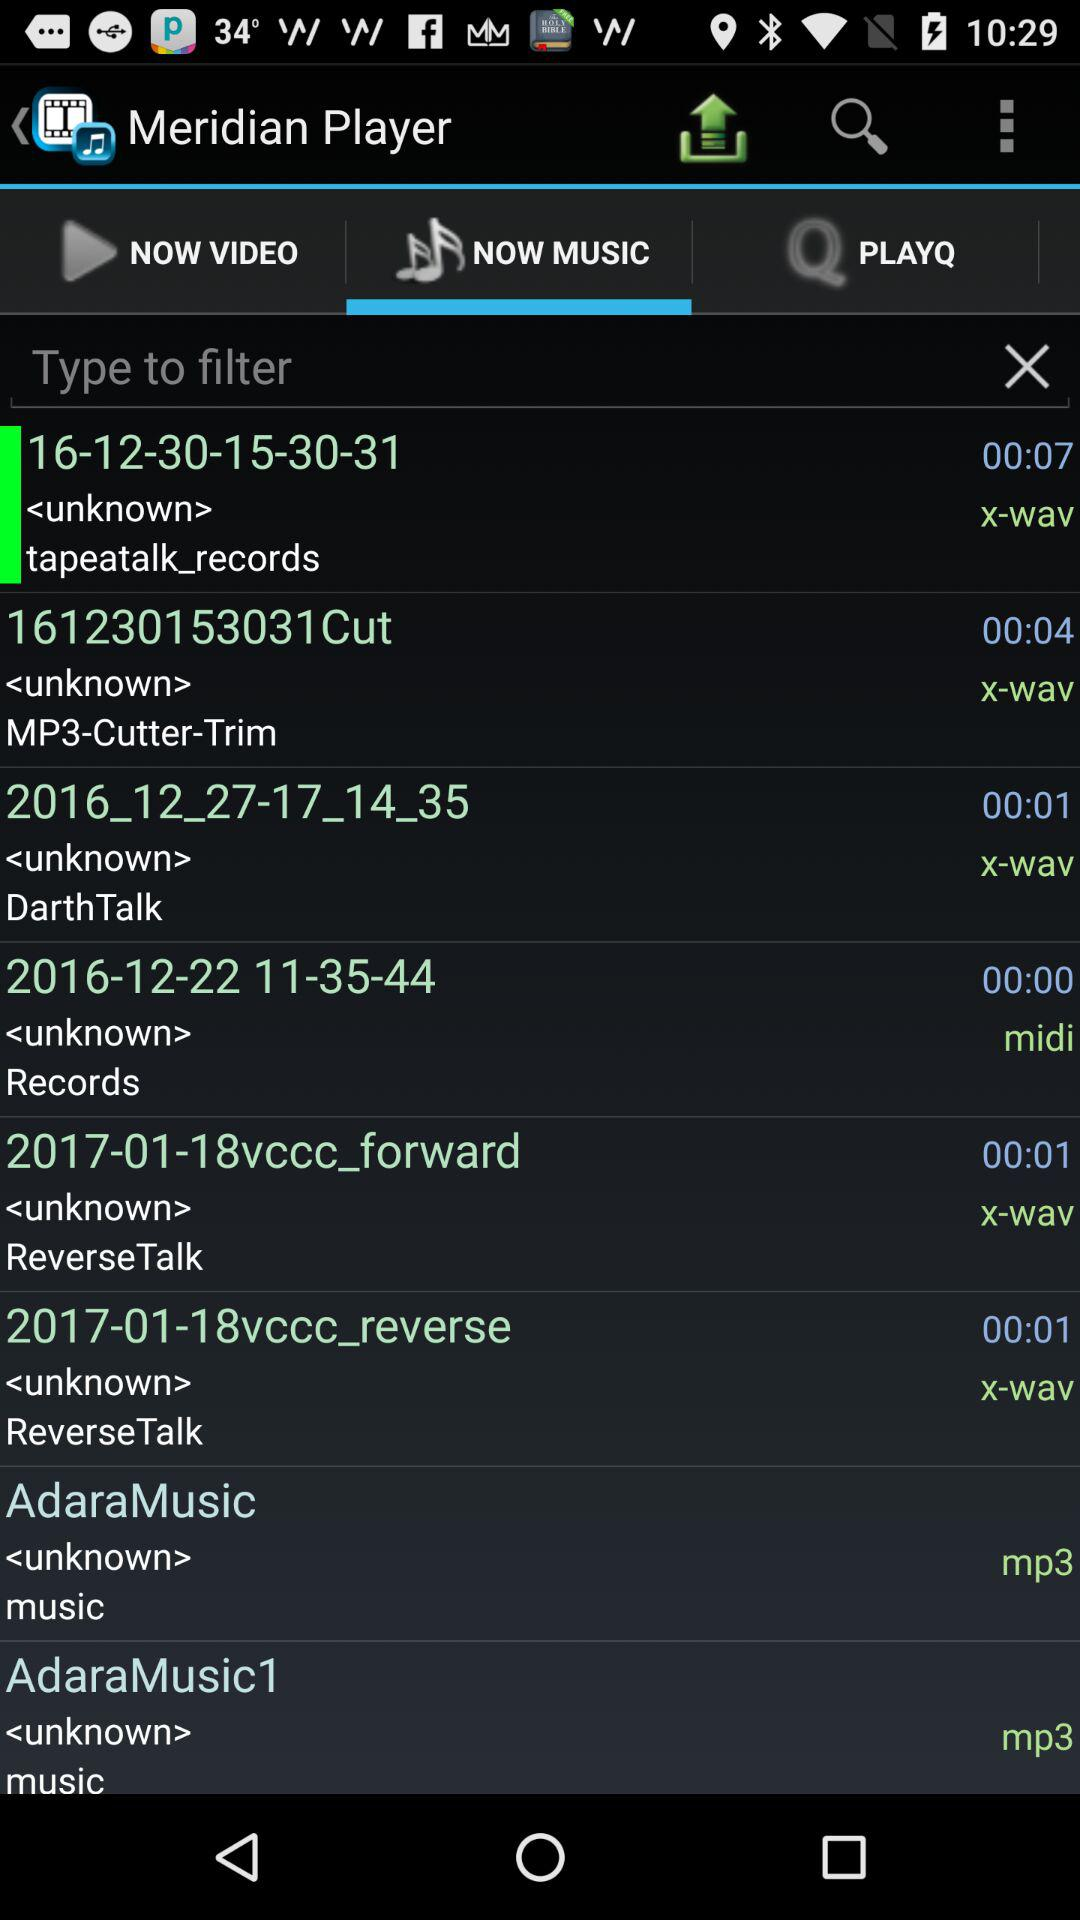What is the name of the application? The name of the application is "Meridian Player". 